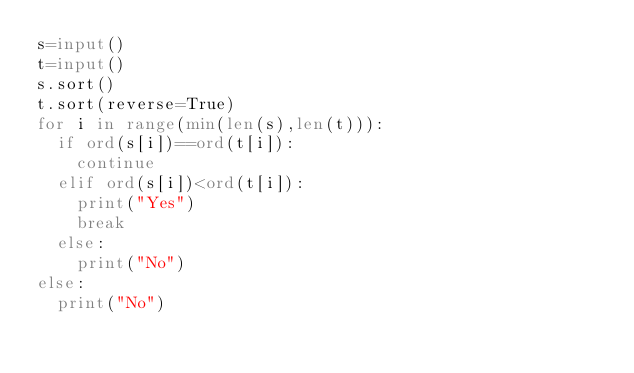<code> <loc_0><loc_0><loc_500><loc_500><_Python_>s=input()
t=input()
s.sort()
t.sort(reverse=True)
for i in range(min(len(s),len(t))):
  if ord(s[i])==ord(t[i]):
    continue
  elif ord(s[i])<ord(t[i]):
    print("Yes")
    break
  else:
    print("No")
else:
  print("No")</code> 